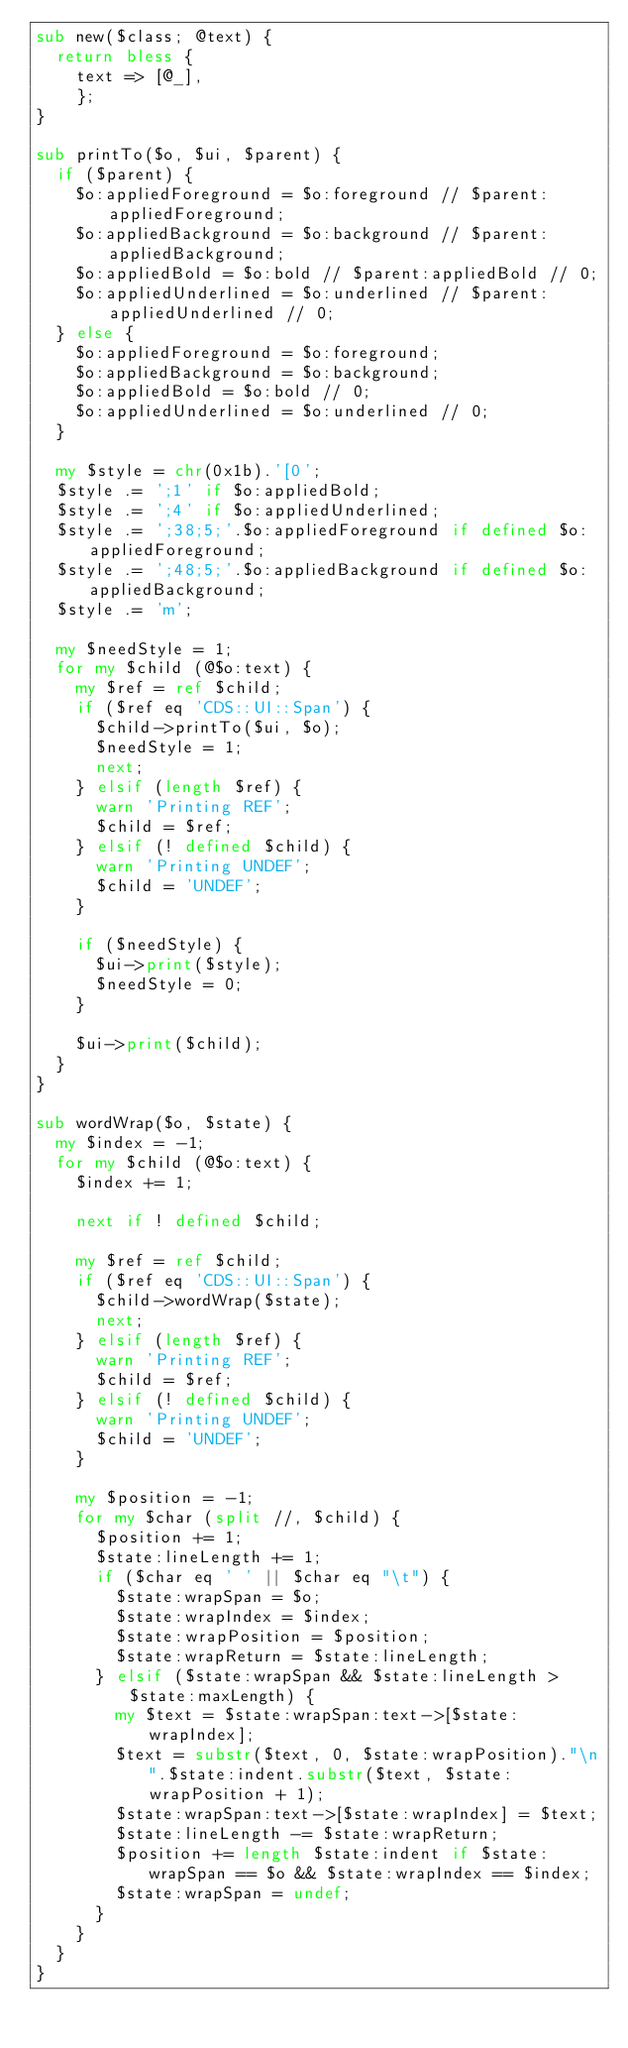<code> <loc_0><loc_0><loc_500><loc_500><_Perl_>sub new($class; @text) {
	return bless {
		text => [@_],
		};
}

sub printTo($o, $ui, $parent) {
	if ($parent) {
		$o:appliedForeground = $o:foreground // $parent:appliedForeground;
		$o:appliedBackground = $o:background // $parent:appliedBackground;
		$o:appliedBold = $o:bold // $parent:appliedBold // 0;
		$o:appliedUnderlined = $o:underlined // $parent:appliedUnderlined // 0;
	} else {
		$o:appliedForeground = $o:foreground;
		$o:appliedBackground = $o:background;
		$o:appliedBold = $o:bold // 0;
		$o:appliedUnderlined = $o:underlined // 0;
	}

	my $style = chr(0x1b).'[0';
	$style .= ';1' if $o:appliedBold;
	$style .= ';4' if $o:appliedUnderlined;
	$style .= ';38;5;'.$o:appliedForeground if defined $o:appliedForeground;
	$style .= ';48;5;'.$o:appliedBackground if defined $o:appliedBackground;
	$style .= 'm';

	my $needStyle = 1;
	for my $child (@$o:text) {
		my $ref = ref $child;
		if ($ref eq 'CDS::UI::Span') {
			$child->printTo($ui, $o);
			$needStyle = 1;
			next;
		} elsif (length $ref) {
			warn 'Printing REF';
			$child = $ref;
		} elsif (! defined $child) {
			warn 'Printing UNDEF';
			$child = 'UNDEF';
		}

		if ($needStyle) {
			$ui->print($style);
			$needStyle = 0;
		}

		$ui->print($child);
	}
}

sub wordWrap($o, $state) {
	my $index = -1;
	for my $child (@$o:text) {
		$index += 1;

		next if ! defined $child;

		my $ref = ref $child;
		if ($ref eq 'CDS::UI::Span') {
			$child->wordWrap($state);
			next;
		} elsif (length $ref) {
			warn 'Printing REF';
			$child = $ref;
		} elsif (! defined $child) {
			warn 'Printing UNDEF';
			$child = 'UNDEF';
		}

		my $position = -1;
		for my $char (split //, $child) {
			$position += 1;
			$state:lineLength += 1;
			if ($char eq ' ' || $char eq "\t") {
				$state:wrapSpan = $o;
				$state:wrapIndex = $index;
				$state:wrapPosition = $position;
				$state:wrapReturn = $state:lineLength;
			} elsif ($state:wrapSpan && $state:lineLength > $state:maxLength) {
				my $text = $state:wrapSpan:text->[$state:wrapIndex];
				$text = substr($text, 0, $state:wrapPosition)."\n".$state:indent.substr($text, $state:wrapPosition + 1);
				$state:wrapSpan:text->[$state:wrapIndex] = $text;
				$state:lineLength -= $state:wrapReturn;
				$position += length $state:indent if $state:wrapSpan == $o && $state:wrapIndex == $index;
				$state:wrapSpan = undef;
			}
		}
	}
}
</code> 